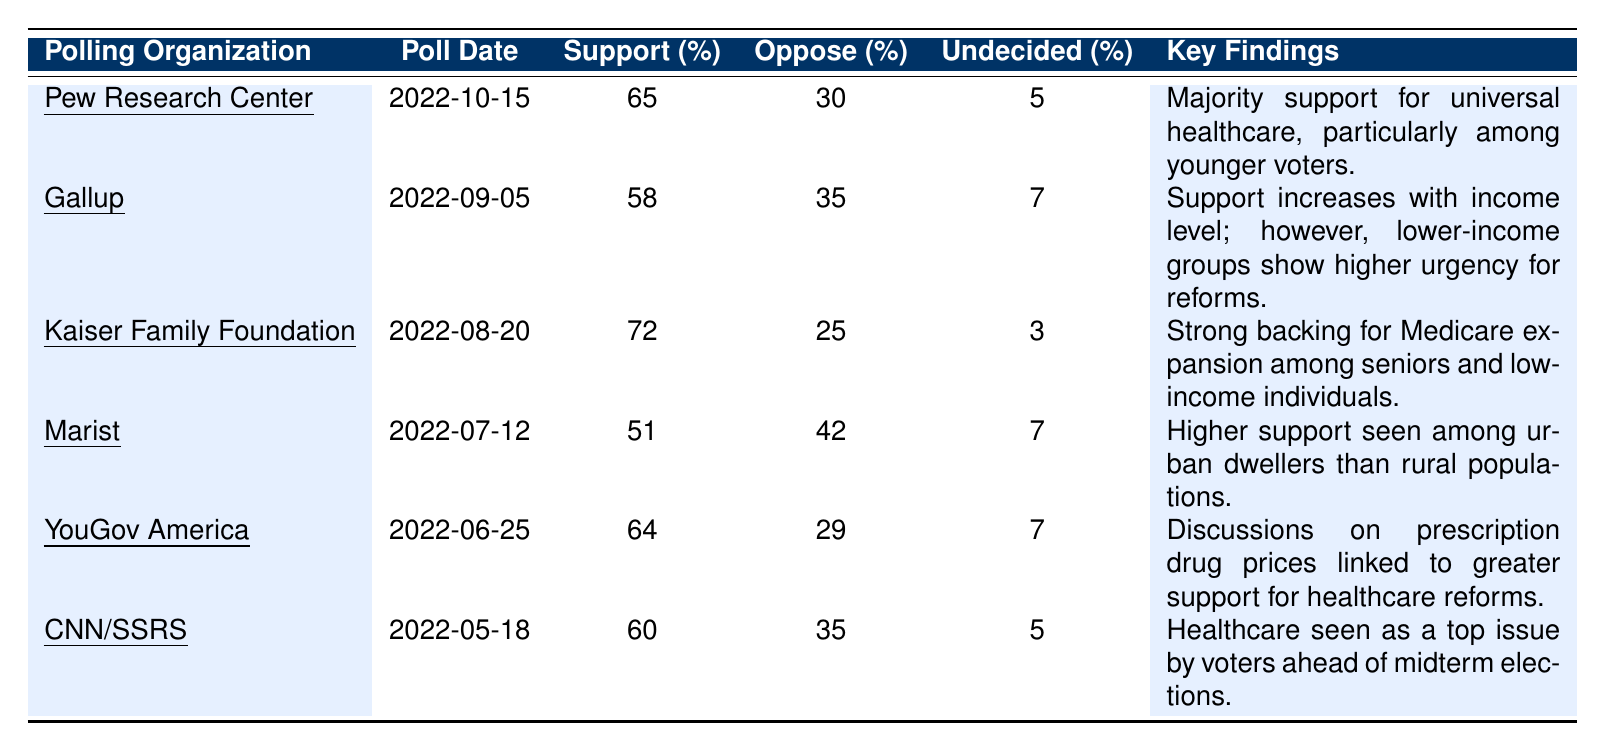What is the percentage of support for healthcare reform according to the Pew Research Center? The Pew Research Center's data shows 65% support for healthcare reform based on its poll conducted on October 15, 2022.
Answer: 65% Which polling organization reported the highest percentage of support for healthcare reform? The Kaiser Family Foundation reported the highest support at 72% on August 20, 2022.
Answer: Kaiser Family Foundation What is the percentage of undecided respondents in the Marist poll? The Marist poll indicated that 7% of respondents were undecided about healthcare reform, as shown in the data from July 12, 2022.
Answer: 7% Calculate the average percentage of support for healthcare reform across all the polls listed. The support percentages are 65, 58, 72, 51, 64, and 60. Summing these gives 65 + 58 + 72 + 51 + 64 + 60 = 390. Dividing by the number of polls (6), the average is 390/6 = 65.
Answer: 65 Which polling organization had the lowest opposition percentage? Marist had the lowest opposition percentage with 42% as indicated in its poll from July 12, 2022, compared to the others which ranged higher.
Answer: Marist Is there a correlation between the support for reform and the polling organizations' focus on specific demographics? Yes, the Kaiser Family Foundation's high support at 72% aligns with its findings regarding seniors and low-income individuals, suggesting a demographic influence on support levels.
Answer: Yes What key finding was common among polls conducted by Pew Research Center and CNN/SSRS regarding demographics? Both polls indicate a focus on younger voters for Pew and a general urgency among voters about healthcare issues according to CNN, highlighting the significance of demographics in their findings.
Answer: Yes Determine the difference in percentage between the highest and lowest support for healthcare reform found in these polls. The highest support is 72% from Kaiser Family Foundation and the lowest is 51% from Marist. The difference is 72 - 51 = 21.
Answer: 21 Is there a trend in support increasing or decreasing according to the dates of the polls? Observing the polls in chronological order, support initially varied but showed some increase toward the later dates, with the highest support observed in August 2022, suggesting fluctuating sentiments over time.
Answer: Yes What do the majority of polls indicate regarding support for universal healthcare? The majority (four out of six polls) report support levels above 50%, indicating a general consensus among respondents favoring universal healthcare reforms.
Answer: Yes 